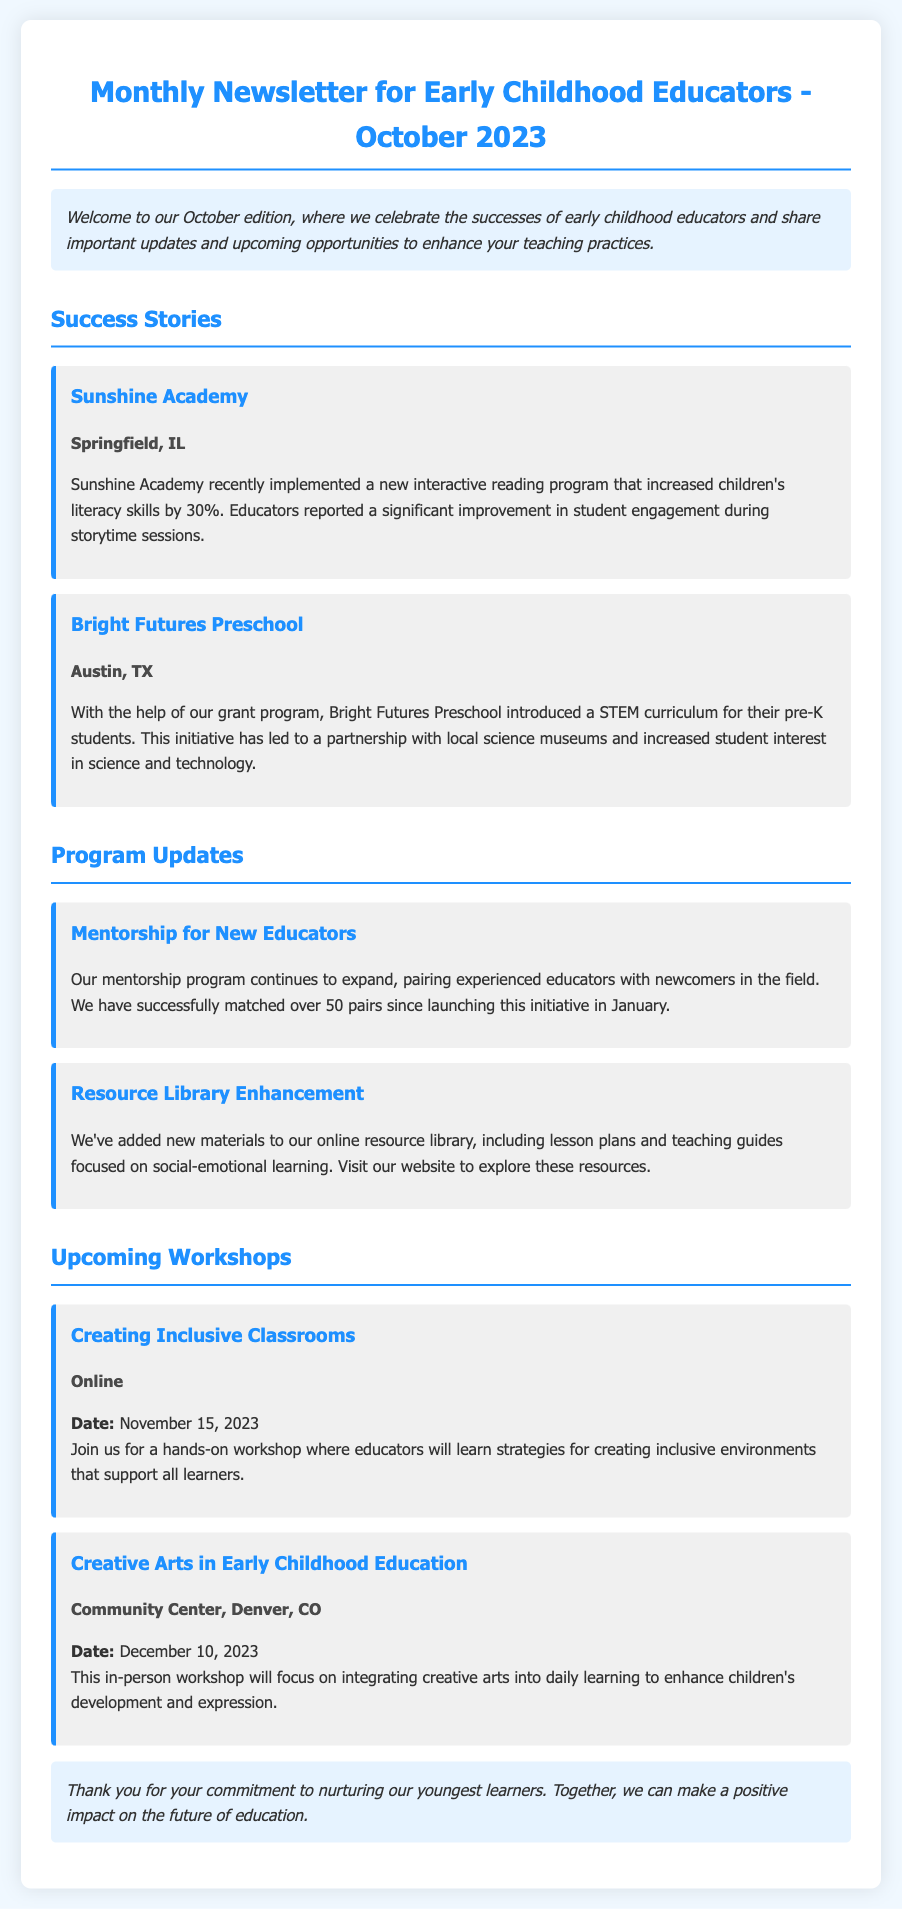What is the title of the newsletter? The title of the newsletter is located at the top of the document.
Answer: Monthly Newsletter for Early Childhood Educators - October 2023 How many success stories are mentioned? The document lists the number of success stories provided in the section.
Answer: 2 What is the location of Sunshine Academy? The location is provided directly under the name of Sunshine Academy.
Answer: Springfield, IL What date is the workshop "Creating Inclusive Classrooms" scheduled for? The date of the workshop is included in the workshop details section.
Answer: November 15, 2023 Which preschool introduced a STEM curriculum? The name of the preschool is stated in the corresponding success story.
Answer: Bright Futures Preschool How many pairs have been matched in the mentorship program? The number of pairs is mentioned in the program updates section.
Answer: 50 What is a focus of the new materials added to the resource library? The focus is described in the program updates section.
Answer: Social-emotional learning Where will the "Creative Arts in Early Childhood Education" workshop take place? The location is noted in the workshop details.
Answer: Community Center, Denver, CO What is the main objective of the October newsletter? The main objective is outlined at the beginning of the document.
Answer: Celebrate successes and share updates 